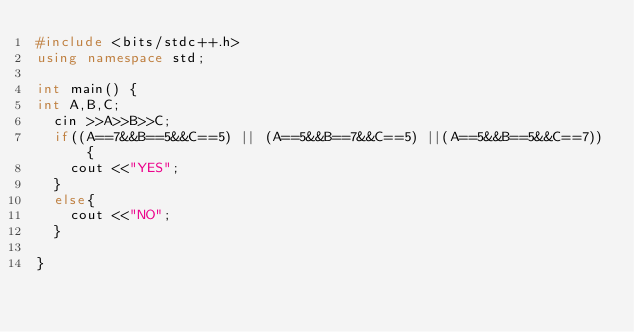<code> <loc_0><loc_0><loc_500><loc_500><_C++_>#include <bits/stdc++.h>
using namespace std;

int main() {
int A,B,C;
  cin >>A>>B>>C;
  if((A==7&&B==5&&C==5) || (A==5&&B==7&&C==5) ||(A==5&&B==5&&C==7)){
    cout <<"YES";
  }
  else{
    cout <<"NO";
  }

}
 </code> 